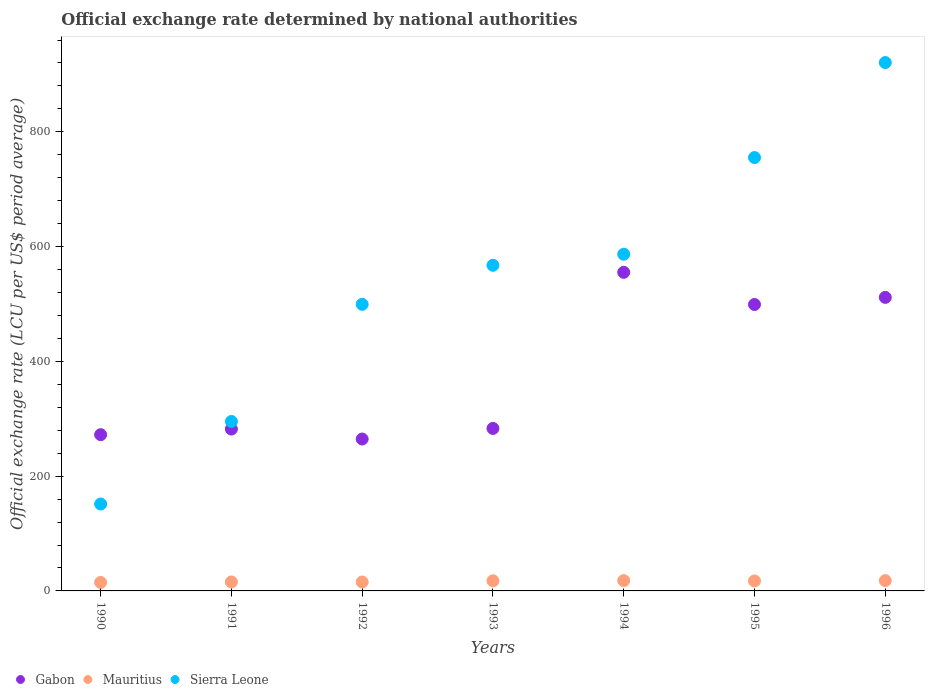Is the number of dotlines equal to the number of legend labels?
Offer a very short reply. Yes. What is the official exchange rate in Sierra Leone in 1996?
Offer a terse response. 920.73. Across all years, what is the maximum official exchange rate in Sierra Leone?
Your answer should be compact. 920.73. Across all years, what is the minimum official exchange rate in Sierra Leone?
Offer a terse response. 151.45. What is the total official exchange rate in Mauritius in the graph?
Provide a succinct answer. 117.02. What is the difference between the official exchange rate in Sierra Leone in 1993 and that in 1996?
Offer a very short reply. -353.27. What is the difference between the official exchange rate in Gabon in 1991 and the official exchange rate in Mauritius in 1996?
Provide a short and direct response. 264.16. What is the average official exchange rate in Mauritius per year?
Ensure brevity in your answer.  16.72. In the year 1990, what is the difference between the official exchange rate in Gabon and official exchange rate in Sierra Leone?
Your answer should be compact. 120.82. In how many years, is the official exchange rate in Mauritius greater than 640 LCU?
Provide a succinct answer. 0. What is the ratio of the official exchange rate in Gabon in 1990 to that in 1992?
Provide a succinct answer. 1.03. Is the difference between the official exchange rate in Gabon in 1994 and 1995 greater than the difference between the official exchange rate in Sierra Leone in 1994 and 1995?
Offer a very short reply. Yes. What is the difference between the highest and the second highest official exchange rate in Mauritius?
Make the answer very short. 0.01. What is the difference between the highest and the lowest official exchange rate in Sierra Leone?
Offer a terse response. 769.29. In how many years, is the official exchange rate in Sierra Leone greater than the average official exchange rate in Sierra Leone taken over all years?
Your answer should be compact. 4. Is the sum of the official exchange rate in Mauritius in 1990 and 1992 greater than the maximum official exchange rate in Gabon across all years?
Offer a very short reply. No. Is it the case that in every year, the sum of the official exchange rate in Mauritius and official exchange rate in Sierra Leone  is greater than the official exchange rate in Gabon?
Offer a very short reply. No. Does the official exchange rate in Sierra Leone monotonically increase over the years?
Your answer should be very brief. Yes. How many years are there in the graph?
Your answer should be very brief. 7. Does the graph contain any zero values?
Your response must be concise. No. Where does the legend appear in the graph?
Make the answer very short. Bottom left. How are the legend labels stacked?
Your answer should be very brief. Horizontal. What is the title of the graph?
Offer a very short reply. Official exchange rate determined by national authorities. Does "Guyana" appear as one of the legend labels in the graph?
Offer a very short reply. No. What is the label or title of the Y-axis?
Ensure brevity in your answer.  Official exchange rate (LCU per US$ period average). What is the Official exchange rate (LCU per US$ period average) of Gabon in 1990?
Make the answer very short. 272.26. What is the Official exchange rate (LCU per US$ period average) of Mauritius in 1990?
Keep it short and to the point. 14.86. What is the Official exchange rate (LCU per US$ period average) of Sierra Leone in 1990?
Give a very brief answer. 151.45. What is the Official exchange rate (LCU per US$ period average) of Gabon in 1991?
Ensure brevity in your answer.  282.11. What is the Official exchange rate (LCU per US$ period average) in Mauritius in 1991?
Provide a short and direct response. 15.65. What is the Official exchange rate (LCU per US$ period average) in Sierra Leone in 1991?
Give a very brief answer. 295.34. What is the Official exchange rate (LCU per US$ period average) of Gabon in 1992?
Provide a short and direct response. 264.69. What is the Official exchange rate (LCU per US$ period average) in Mauritius in 1992?
Offer a very short reply. 15.56. What is the Official exchange rate (LCU per US$ period average) in Sierra Leone in 1992?
Ensure brevity in your answer.  499.44. What is the Official exchange rate (LCU per US$ period average) of Gabon in 1993?
Give a very brief answer. 283.16. What is the Official exchange rate (LCU per US$ period average) of Mauritius in 1993?
Your answer should be compact. 17.65. What is the Official exchange rate (LCU per US$ period average) of Sierra Leone in 1993?
Your answer should be compact. 567.46. What is the Official exchange rate (LCU per US$ period average) in Gabon in 1994?
Keep it short and to the point. 555.2. What is the Official exchange rate (LCU per US$ period average) in Mauritius in 1994?
Offer a very short reply. 17.96. What is the Official exchange rate (LCU per US$ period average) in Sierra Leone in 1994?
Offer a very short reply. 586.74. What is the Official exchange rate (LCU per US$ period average) in Gabon in 1995?
Ensure brevity in your answer.  499.15. What is the Official exchange rate (LCU per US$ period average) in Mauritius in 1995?
Give a very brief answer. 17.39. What is the Official exchange rate (LCU per US$ period average) of Sierra Leone in 1995?
Provide a short and direct response. 755.22. What is the Official exchange rate (LCU per US$ period average) in Gabon in 1996?
Your answer should be compact. 511.55. What is the Official exchange rate (LCU per US$ period average) of Mauritius in 1996?
Make the answer very short. 17.95. What is the Official exchange rate (LCU per US$ period average) of Sierra Leone in 1996?
Provide a short and direct response. 920.73. Across all years, what is the maximum Official exchange rate (LCU per US$ period average) of Gabon?
Ensure brevity in your answer.  555.2. Across all years, what is the maximum Official exchange rate (LCU per US$ period average) in Mauritius?
Provide a short and direct response. 17.96. Across all years, what is the maximum Official exchange rate (LCU per US$ period average) in Sierra Leone?
Your response must be concise. 920.73. Across all years, what is the minimum Official exchange rate (LCU per US$ period average) of Gabon?
Offer a very short reply. 264.69. Across all years, what is the minimum Official exchange rate (LCU per US$ period average) in Mauritius?
Ensure brevity in your answer.  14.86. Across all years, what is the minimum Official exchange rate (LCU per US$ period average) in Sierra Leone?
Your answer should be compact. 151.45. What is the total Official exchange rate (LCU per US$ period average) in Gabon in the graph?
Make the answer very short. 2668.13. What is the total Official exchange rate (LCU per US$ period average) of Mauritius in the graph?
Provide a succinct answer. 117.02. What is the total Official exchange rate (LCU per US$ period average) of Sierra Leone in the graph?
Ensure brevity in your answer.  3776.38. What is the difference between the Official exchange rate (LCU per US$ period average) of Gabon in 1990 and that in 1991?
Give a very brief answer. -9.84. What is the difference between the Official exchange rate (LCU per US$ period average) of Mauritius in 1990 and that in 1991?
Your response must be concise. -0.79. What is the difference between the Official exchange rate (LCU per US$ period average) of Sierra Leone in 1990 and that in 1991?
Give a very brief answer. -143.9. What is the difference between the Official exchange rate (LCU per US$ period average) of Gabon in 1990 and that in 1992?
Give a very brief answer. 7.57. What is the difference between the Official exchange rate (LCU per US$ period average) in Mauritius in 1990 and that in 1992?
Your response must be concise. -0.7. What is the difference between the Official exchange rate (LCU per US$ period average) of Sierra Leone in 1990 and that in 1992?
Provide a short and direct response. -348. What is the difference between the Official exchange rate (LCU per US$ period average) of Gabon in 1990 and that in 1993?
Your answer should be very brief. -10.9. What is the difference between the Official exchange rate (LCU per US$ period average) in Mauritius in 1990 and that in 1993?
Provide a short and direct response. -2.78. What is the difference between the Official exchange rate (LCU per US$ period average) in Sierra Leone in 1990 and that in 1993?
Your answer should be very brief. -416.01. What is the difference between the Official exchange rate (LCU per US$ period average) of Gabon in 1990 and that in 1994?
Provide a short and direct response. -282.94. What is the difference between the Official exchange rate (LCU per US$ period average) in Mauritius in 1990 and that in 1994?
Offer a very short reply. -3.1. What is the difference between the Official exchange rate (LCU per US$ period average) in Sierra Leone in 1990 and that in 1994?
Offer a terse response. -435.29. What is the difference between the Official exchange rate (LCU per US$ period average) of Gabon in 1990 and that in 1995?
Ensure brevity in your answer.  -226.88. What is the difference between the Official exchange rate (LCU per US$ period average) in Mauritius in 1990 and that in 1995?
Provide a succinct answer. -2.52. What is the difference between the Official exchange rate (LCU per US$ period average) in Sierra Leone in 1990 and that in 1995?
Provide a short and direct response. -603.77. What is the difference between the Official exchange rate (LCU per US$ period average) in Gabon in 1990 and that in 1996?
Your response must be concise. -239.29. What is the difference between the Official exchange rate (LCU per US$ period average) of Mauritius in 1990 and that in 1996?
Make the answer very short. -3.08. What is the difference between the Official exchange rate (LCU per US$ period average) in Sierra Leone in 1990 and that in 1996?
Your response must be concise. -769.29. What is the difference between the Official exchange rate (LCU per US$ period average) in Gabon in 1991 and that in 1992?
Provide a short and direct response. 17.42. What is the difference between the Official exchange rate (LCU per US$ period average) in Mauritius in 1991 and that in 1992?
Give a very brief answer. 0.09. What is the difference between the Official exchange rate (LCU per US$ period average) of Sierra Leone in 1991 and that in 1992?
Your response must be concise. -204.1. What is the difference between the Official exchange rate (LCU per US$ period average) of Gabon in 1991 and that in 1993?
Your answer should be very brief. -1.06. What is the difference between the Official exchange rate (LCU per US$ period average) in Mauritius in 1991 and that in 1993?
Make the answer very short. -2. What is the difference between the Official exchange rate (LCU per US$ period average) of Sierra Leone in 1991 and that in 1993?
Provide a succinct answer. -272.11. What is the difference between the Official exchange rate (LCU per US$ period average) in Gabon in 1991 and that in 1994?
Offer a terse response. -273.1. What is the difference between the Official exchange rate (LCU per US$ period average) of Mauritius in 1991 and that in 1994?
Make the answer very short. -2.31. What is the difference between the Official exchange rate (LCU per US$ period average) in Sierra Leone in 1991 and that in 1994?
Provide a succinct answer. -291.4. What is the difference between the Official exchange rate (LCU per US$ period average) of Gabon in 1991 and that in 1995?
Provide a succinct answer. -217.04. What is the difference between the Official exchange rate (LCU per US$ period average) in Mauritius in 1991 and that in 1995?
Your answer should be very brief. -1.73. What is the difference between the Official exchange rate (LCU per US$ period average) of Sierra Leone in 1991 and that in 1995?
Offer a very short reply. -459.87. What is the difference between the Official exchange rate (LCU per US$ period average) of Gabon in 1991 and that in 1996?
Provide a succinct answer. -229.45. What is the difference between the Official exchange rate (LCU per US$ period average) in Mauritius in 1991 and that in 1996?
Your answer should be compact. -2.3. What is the difference between the Official exchange rate (LCU per US$ period average) in Sierra Leone in 1991 and that in 1996?
Provide a succinct answer. -625.39. What is the difference between the Official exchange rate (LCU per US$ period average) of Gabon in 1992 and that in 1993?
Offer a terse response. -18.47. What is the difference between the Official exchange rate (LCU per US$ period average) in Mauritius in 1992 and that in 1993?
Keep it short and to the point. -2.08. What is the difference between the Official exchange rate (LCU per US$ period average) of Sierra Leone in 1992 and that in 1993?
Offer a very short reply. -68.02. What is the difference between the Official exchange rate (LCU per US$ period average) in Gabon in 1992 and that in 1994?
Ensure brevity in your answer.  -290.51. What is the difference between the Official exchange rate (LCU per US$ period average) of Mauritius in 1992 and that in 1994?
Your response must be concise. -2.4. What is the difference between the Official exchange rate (LCU per US$ period average) in Sierra Leone in 1992 and that in 1994?
Offer a very short reply. -87.3. What is the difference between the Official exchange rate (LCU per US$ period average) of Gabon in 1992 and that in 1995?
Make the answer very short. -234.46. What is the difference between the Official exchange rate (LCU per US$ period average) in Mauritius in 1992 and that in 1995?
Ensure brevity in your answer.  -1.82. What is the difference between the Official exchange rate (LCU per US$ period average) in Sierra Leone in 1992 and that in 1995?
Offer a very short reply. -255.77. What is the difference between the Official exchange rate (LCU per US$ period average) in Gabon in 1992 and that in 1996?
Your answer should be very brief. -246.86. What is the difference between the Official exchange rate (LCU per US$ period average) in Mauritius in 1992 and that in 1996?
Give a very brief answer. -2.38. What is the difference between the Official exchange rate (LCU per US$ period average) of Sierra Leone in 1992 and that in 1996?
Offer a very short reply. -421.29. What is the difference between the Official exchange rate (LCU per US$ period average) in Gabon in 1993 and that in 1994?
Offer a very short reply. -272.04. What is the difference between the Official exchange rate (LCU per US$ period average) in Mauritius in 1993 and that in 1994?
Offer a terse response. -0.31. What is the difference between the Official exchange rate (LCU per US$ period average) of Sierra Leone in 1993 and that in 1994?
Provide a short and direct response. -19.28. What is the difference between the Official exchange rate (LCU per US$ period average) in Gabon in 1993 and that in 1995?
Give a very brief answer. -215.99. What is the difference between the Official exchange rate (LCU per US$ period average) in Mauritius in 1993 and that in 1995?
Give a very brief answer. 0.26. What is the difference between the Official exchange rate (LCU per US$ period average) of Sierra Leone in 1993 and that in 1995?
Your response must be concise. -187.76. What is the difference between the Official exchange rate (LCU per US$ period average) in Gabon in 1993 and that in 1996?
Provide a succinct answer. -228.39. What is the difference between the Official exchange rate (LCU per US$ period average) in Sierra Leone in 1993 and that in 1996?
Offer a very short reply. -353.27. What is the difference between the Official exchange rate (LCU per US$ period average) in Gabon in 1994 and that in 1995?
Make the answer very short. 56.06. What is the difference between the Official exchange rate (LCU per US$ period average) in Mauritius in 1994 and that in 1995?
Provide a short and direct response. 0.57. What is the difference between the Official exchange rate (LCU per US$ period average) in Sierra Leone in 1994 and that in 1995?
Provide a short and direct response. -168.48. What is the difference between the Official exchange rate (LCU per US$ period average) in Gabon in 1994 and that in 1996?
Ensure brevity in your answer.  43.65. What is the difference between the Official exchange rate (LCU per US$ period average) of Mauritius in 1994 and that in 1996?
Give a very brief answer. 0.01. What is the difference between the Official exchange rate (LCU per US$ period average) of Sierra Leone in 1994 and that in 1996?
Your answer should be compact. -333.99. What is the difference between the Official exchange rate (LCU per US$ period average) of Gabon in 1995 and that in 1996?
Your response must be concise. -12.4. What is the difference between the Official exchange rate (LCU per US$ period average) in Mauritius in 1995 and that in 1996?
Give a very brief answer. -0.56. What is the difference between the Official exchange rate (LCU per US$ period average) in Sierra Leone in 1995 and that in 1996?
Give a very brief answer. -165.52. What is the difference between the Official exchange rate (LCU per US$ period average) of Gabon in 1990 and the Official exchange rate (LCU per US$ period average) of Mauritius in 1991?
Provide a succinct answer. 256.61. What is the difference between the Official exchange rate (LCU per US$ period average) in Gabon in 1990 and the Official exchange rate (LCU per US$ period average) in Sierra Leone in 1991?
Your answer should be very brief. -23.08. What is the difference between the Official exchange rate (LCU per US$ period average) in Mauritius in 1990 and the Official exchange rate (LCU per US$ period average) in Sierra Leone in 1991?
Your response must be concise. -280.48. What is the difference between the Official exchange rate (LCU per US$ period average) in Gabon in 1990 and the Official exchange rate (LCU per US$ period average) in Mauritius in 1992?
Provide a short and direct response. 256.7. What is the difference between the Official exchange rate (LCU per US$ period average) of Gabon in 1990 and the Official exchange rate (LCU per US$ period average) of Sierra Leone in 1992?
Offer a terse response. -227.18. What is the difference between the Official exchange rate (LCU per US$ period average) of Mauritius in 1990 and the Official exchange rate (LCU per US$ period average) of Sierra Leone in 1992?
Ensure brevity in your answer.  -484.58. What is the difference between the Official exchange rate (LCU per US$ period average) in Gabon in 1990 and the Official exchange rate (LCU per US$ period average) in Mauritius in 1993?
Give a very brief answer. 254.62. What is the difference between the Official exchange rate (LCU per US$ period average) of Gabon in 1990 and the Official exchange rate (LCU per US$ period average) of Sierra Leone in 1993?
Offer a terse response. -295.19. What is the difference between the Official exchange rate (LCU per US$ period average) of Mauritius in 1990 and the Official exchange rate (LCU per US$ period average) of Sierra Leone in 1993?
Your answer should be very brief. -552.6. What is the difference between the Official exchange rate (LCU per US$ period average) in Gabon in 1990 and the Official exchange rate (LCU per US$ period average) in Mauritius in 1994?
Keep it short and to the point. 254.3. What is the difference between the Official exchange rate (LCU per US$ period average) of Gabon in 1990 and the Official exchange rate (LCU per US$ period average) of Sierra Leone in 1994?
Your answer should be compact. -314.47. What is the difference between the Official exchange rate (LCU per US$ period average) of Mauritius in 1990 and the Official exchange rate (LCU per US$ period average) of Sierra Leone in 1994?
Ensure brevity in your answer.  -571.88. What is the difference between the Official exchange rate (LCU per US$ period average) in Gabon in 1990 and the Official exchange rate (LCU per US$ period average) in Mauritius in 1995?
Provide a succinct answer. 254.88. What is the difference between the Official exchange rate (LCU per US$ period average) of Gabon in 1990 and the Official exchange rate (LCU per US$ period average) of Sierra Leone in 1995?
Provide a succinct answer. -482.95. What is the difference between the Official exchange rate (LCU per US$ period average) in Mauritius in 1990 and the Official exchange rate (LCU per US$ period average) in Sierra Leone in 1995?
Your response must be concise. -740.35. What is the difference between the Official exchange rate (LCU per US$ period average) of Gabon in 1990 and the Official exchange rate (LCU per US$ period average) of Mauritius in 1996?
Offer a very short reply. 254.32. What is the difference between the Official exchange rate (LCU per US$ period average) in Gabon in 1990 and the Official exchange rate (LCU per US$ period average) in Sierra Leone in 1996?
Give a very brief answer. -648.47. What is the difference between the Official exchange rate (LCU per US$ period average) in Mauritius in 1990 and the Official exchange rate (LCU per US$ period average) in Sierra Leone in 1996?
Your answer should be very brief. -905.87. What is the difference between the Official exchange rate (LCU per US$ period average) of Gabon in 1991 and the Official exchange rate (LCU per US$ period average) of Mauritius in 1992?
Offer a terse response. 266.54. What is the difference between the Official exchange rate (LCU per US$ period average) of Gabon in 1991 and the Official exchange rate (LCU per US$ period average) of Sierra Leone in 1992?
Offer a terse response. -217.33. What is the difference between the Official exchange rate (LCU per US$ period average) in Mauritius in 1991 and the Official exchange rate (LCU per US$ period average) in Sierra Leone in 1992?
Your response must be concise. -483.79. What is the difference between the Official exchange rate (LCU per US$ period average) of Gabon in 1991 and the Official exchange rate (LCU per US$ period average) of Mauritius in 1993?
Offer a terse response. 264.46. What is the difference between the Official exchange rate (LCU per US$ period average) in Gabon in 1991 and the Official exchange rate (LCU per US$ period average) in Sierra Leone in 1993?
Give a very brief answer. -285.35. What is the difference between the Official exchange rate (LCU per US$ period average) of Mauritius in 1991 and the Official exchange rate (LCU per US$ period average) of Sierra Leone in 1993?
Provide a succinct answer. -551.81. What is the difference between the Official exchange rate (LCU per US$ period average) in Gabon in 1991 and the Official exchange rate (LCU per US$ period average) in Mauritius in 1994?
Offer a very short reply. 264.15. What is the difference between the Official exchange rate (LCU per US$ period average) of Gabon in 1991 and the Official exchange rate (LCU per US$ period average) of Sierra Leone in 1994?
Offer a terse response. -304.63. What is the difference between the Official exchange rate (LCU per US$ period average) in Mauritius in 1991 and the Official exchange rate (LCU per US$ period average) in Sierra Leone in 1994?
Offer a terse response. -571.09. What is the difference between the Official exchange rate (LCU per US$ period average) in Gabon in 1991 and the Official exchange rate (LCU per US$ period average) in Mauritius in 1995?
Provide a succinct answer. 264.72. What is the difference between the Official exchange rate (LCU per US$ period average) of Gabon in 1991 and the Official exchange rate (LCU per US$ period average) of Sierra Leone in 1995?
Make the answer very short. -473.11. What is the difference between the Official exchange rate (LCU per US$ period average) in Mauritius in 1991 and the Official exchange rate (LCU per US$ period average) in Sierra Leone in 1995?
Offer a very short reply. -739.56. What is the difference between the Official exchange rate (LCU per US$ period average) in Gabon in 1991 and the Official exchange rate (LCU per US$ period average) in Mauritius in 1996?
Ensure brevity in your answer.  264.16. What is the difference between the Official exchange rate (LCU per US$ period average) of Gabon in 1991 and the Official exchange rate (LCU per US$ period average) of Sierra Leone in 1996?
Ensure brevity in your answer.  -638.63. What is the difference between the Official exchange rate (LCU per US$ period average) of Mauritius in 1991 and the Official exchange rate (LCU per US$ period average) of Sierra Leone in 1996?
Your response must be concise. -905.08. What is the difference between the Official exchange rate (LCU per US$ period average) in Gabon in 1992 and the Official exchange rate (LCU per US$ period average) in Mauritius in 1993?
Give a very brief answer. 247.04. What is the difference between the Official exchange rate (LCU per US$ period average) in Gabon in 1992 and the Official exchange rate (LCU per US$ period average) in Sierra Leone in 1993?
Your answer should be very brief. -302.77. What is the difference between the Official exchange rate (LCU per US$ period average) of Mauritius in 1992 and the Official exchange rate (LCU per US$ period average) of Sierra Leone in 1993?
Ensure brevity in your answer.  -551.9. What is the difference between the Official exchange rate (LCU per US$ period average) in Gabon in 1992 and the Official exchange rate (LCU per US$ period average) in Mauritius in 1994?
Ensure brevity in your answer.  246.73. What is the difference between the Official exchange rate (LCU per US$ period average) in Gabon in 1992 and the Official exchange rate (LCU per US$ period average) in Sierra Leone in 1994?
Your response must be concise. -322.05. What is the difference between the Official exchange rate (LCU per US$ period average) in Mauritius in 1992 and the Official exchange rate (LCU per US$ period average) in Sierra Leone in 1994?
Offer a terse response. -571.18. What is the difference between the Official exchange rate (LCU per US$ period average) of Gabon in 1992 and the Official exchange rate (LCU per US$ period average) of Mauritius in 1995?
Ensure brevity in your answer.  247.31. What is the difference between the Official exchange rate (LCU per US$ period average) of Gabon in 1992 and the Official exchange rate (LCU per US$ period average) of Sierra Leone in 1995?
Your answer should be compact. -490.52. What is the difference between the Official exchange rate (LCU per US$ period average) of Mauritius in 1992 and the Official exchange rate (LCU per US$ period average) of Sierra Leone in 1995?
Offer a terse response. -739.65. What is the difference between the Official exchange rate (LCU per US$ period average) in Gabon in 1992 and the Official exchange rate (LCU per US$ period average) in Mauritius in 1996?
Make the answer very short. 246.74. What is the difference between the Official exchange rate (LCU per US$ period average) in Gabon in 1992 and the Official exchange rate (LCU per US$ period average) in Sierra Leone in 1996?
Offer a terse response. -656.04. What is the difference between the Official exchange rate (LCU per US$ period average) in Mauritius in 1992 and the Official exchange rate (LCU per US$ period average) in Sierra Leone in 1996?
Provide a succinct answer. -905.17. What is the difference between the Official exchange rate (LCU per US$ period average) of Gabon in 1993 and the Official exchange rate (LCU per US$ period average) of Mauritius in 1994?
Ensure brevity in your answer.  265.2. What is the difference between the Official exchange rate (LCU per US$ period average) in Gabon in 1993 and the Official exchange rate (LCU per US$ period average) in Sierra Leone in 1994?
Make the answer very short. -303.58. What is the difference between the Official exchange rate (LCU per US$ period average) of Mauritius in 1993 and the Official exchange rate (LCU per US$ period average) of Sierra Leone in 1994?
Keep it short and to the point. -569.09. What is the difference between the Official exchange rate (LCU per US$ period average) in Gabon in 1993 and the Official exchange rate (LCU per US$ period average) in Mauritius in 1995?
Provide a succinct answer. 265.78. What is the difference between the Official exchange rate (LCU per US$ period average) of Gabon in 1993 and the Official exchange rate (LCU per US$ period average) of Sierra Leone in 1995?
Provide a short and direct response. -472.05. What is the difference between the Official exchange rate (LCU per US$ period average) in Mauritius in 1993 and the Official exchange rate (LCU per US$ period average) in Sierra Leone in 1995?
Your response must be concise. -737.57. What is the difference between the Official exchange rate (LCU per US$ period average) in Gabon in 1993 and the Official exchange rate (LCU per US$ period average) in Mauritius in 1996?
Ensure brevity in your answer.  265.21. What is the difference between the Official exchange rate (LCU per US$ period average) of Gabon in 1993 and the Official exchange rate (LCU per US$ period average) of Sierra Leone in 1996?
Provide a succinct answer. -637.57. What is the difference between the Official exchange rate (LCU per US$ period average) in Mauritius in 1993 and the Official exchange rate (LCU per US$ period average) in Sierra Leone in 1996?
Give a very brief answer. -903.08. What is the difference between the Official exchange rate (LCU per US$ period average) of Gabon in 1994 and the Official exchange rate (LCU per US$ period average) of Mauritius in 1995?
Offer a very short reply. 537.82. What is the difference between the Official exchange rate (LCU per US$ period average) of Gabon in 1994 and the Official exchange rate (LCU per US$ period average) of Sierra Leone in 1995?
Your response must be concise. -200.01. What is the difference between the Official exchange rate (LCU per US$ period average) of Mauritius in 1994 and the Official exchange rate (LCU per US$ period average) of Sierra Leone in 1995?
Give a very brief answer. -737.26. What is the difference between the Official exchange rate (LCU per US$ period average) of Gabon in 1994 and the Official exchange rate (LCU per US$ period average) of Mauritius in 1996?
Give a very brief answer. 537.26. What is the difference between the Official exchange rate (LCU per US$ period average) of Gabon in 1994 and the Official exchange rate (LCU per US$ period average) of Sierra Leone in 1996?
Keep it short and to the point. -365.53. What is the difference between the Official exchange rate (LCU per US$ period average) in Mauritius in 1994 and the Official exchange rate (LCU per US$ period average) in Sierra Leone in 1996?
Provide a succinct answer. -902.77. What is the difference between the Official exchange rate (LCU per US$ period average) of Gabon in 1995 and the Official exchange rate (LCU per US$ period average) of Mauritius in 1996?
Offer a very short reply. 481.2. What is the difference between the Official exchange rate (LCU per US$ period average) of Gabon in 1995 and the Official exchange rate (LCU per US$ period average) of Sierra Leone in 1996?
Offer a very short reply. -421.58. What is the difference between the Official exchange rate (LCU per US$ period average) in Mauritius in 1995 and the Official exchange rate (LCU per US$ period average) in Sierra Leone in 1996?
Provide a succinct answer. -903.35. What is the average Official exchange rate (LCU per US$ period average) of Gabon per year?
Make the answer very short. 381.16. What is the average Official exchange rate (LCU per US$ period average) in Mauritius per year?
Ensure brevity in your answer.  16.72. What is the average Official exchange rate (LCU per US$ period average) of Sierra Leone per year?
Your answer should be compact. 539.48. In the year 1990, what is the difference between the Official exchange rate (LCU per US$ period average) of Gabon and Official exchange rate (LCU per US$ period average) of Mauritius?
Offer a terse response. 257.4. In the year 1990, what is the difference between the Official exchange rate (LCU per US$ period average) in Gabon and Official exchange rate (LCU per US$ period average) in Sierra Leone?
Give a very brief answer. 120.82. In the year 1990, what is the difference between the Official exchange rate (LCU per US$ period average) in Mauritius and Official exchange rate (LCU per US$ period average) in Sierra Leone?
Give a very brief answer. -136.58. In the year 1991, what is the difference between the Official exchange rate (LCU per US$ period average) of Gabon and Official exchange rate (LCU per US$ period average) of Mauritius?
Ensure brevity in your answer.  266.45. In the year 1991, what is the difference between the Official exchange rate (LCU per US$ period average) of Gabon and Official exchange rate (LCU per US$ period average) of Sierra Leone?
Offer a very short reply. -13.24. In the year 1991, what is the difference between the Official exchange rate (LCU per US$ period average) of Mauritius and Official exchange rate (LCU per US$ period average) of Sierra Leone?
Ensure brevity in your answer.  -279.69. In the year 1992, what is the difference between the Official exchange rate (LCU per US$ period average) in Gabon and Official exchange rate (LCU per US$ period average) in Mauritius?
Ensure brevity in your answer.  249.13. In the year 1992, what is the difference between the Official exchange rate (LCU per US$ period average) in Gabon and Official exchange rate (LCU per US$ period average) in Sierra Leone?
Give a very brief answer. -234.75. In the year 1992, what is the difference between the Official exchange rate (LCU per US$ period average) in Mauritius and Official exchange rate (LCU per US$ period average) in Sierra Leone?
Your answer should be very brief. -483.88. In the year 1993, what is the difference between the Official exchange rate (LCU per US$ period average) in Gabon and Official exchange rate (LCU per US$ period average) in Mauritius?
Your answer should be compact. 265.51. In the year 1993, what is the difference between the Official exchange rate (LCU per US$ period average) of Gabon and Official exchange rate (LCU per US$ period average) of Sierra Leone?
Keep it short and to the point. -284.3. In the year 1993, what is the difference between the Official exchange rate (LCU per US$ period average) of Mauritius and Official exchange rate (LCU per US$ period average) of Sierra Leone?
Keep it short and to the point. -549.81. In the year 1994, what is the difference between the Official exchange rate (LCU per US$ period average) in Gabon and Official exchange rate (LCU per US$ period average) in Mauritius?
Give a very brief answer. 537.24. In the year 1994, what is the difference between the Official exchange rate (LCU per US$ period average) in Gabon and Official exchange rate (LCU per US$ period average) in Sierra Leone?
Your response must be concise. -31.54. In the year 1994, what is the difference between the Official exchange rate (LCU per US$ period average) of Mauritius and Official exchange rate (LCU per US$ period average) of Sierra Leone?
Offer a terse response. -568.78. In the year 1995, what is the difference between the Official exchange rate (LCU per US$ period average) in Gabon and Official exchange rate (LCU per US$ period average) in Mauritius?
Your answer should be compact. 481.76. In the year 1995, what is the difference between the Official exchange rate (LCU per US$ period average) in Gabon and Official exchange rate (LCU per US$ period average) in Sierra Leone?
Keep it short and to the point. -256.07. In the year 1995, what is the difference between the Official exchange rate (LCU per US$ period average) of Mauritius and Official exchange rate (LCU per US$ period average) of Sierra Leone?
Keep it short and to the point. -737.83. In the year 1996, what is the difference between the Official exchange rate (LCU per US$ period average) in Gabon and Official exchange rate (LCU per US$ period average) in Mauritius?
Your response must be concise. 493.6. In the year 1996, what is the difference between the Official exchange rate (LCU per US$ period average) of Gabon and Official exchange rate (LCU per US$ period average) of Sierra Leone?
Provide a succinct answer. -409.18. In the year 1996, what is the difference between the Official exchange rate (LCU per US$ period average) in Mauritius and Official exchange rate (LCU per US$ period average) in Sierra Leone?
Provide a succinct answer. -902.78. What is the ratio of the Official exchange rate (LCU per US$ period average) in Gabon in 1990 to that in 1991?
Give a very brief answer. 0.97. What is the ratio of the Official exchange rate (LCU per US$ period average) in Mauritius in 1990 to that in 1991?
Your answer should be compact. 0.95. What is the ratio of the Official exchange rate (LCU per US$ period average) of Sierra Leone in 1990 to that in 1991?
Keep it short and to the point. 0.51. What is the ratio of the Official exchange rate (LCU per US$ period average) in Gabon in 1990 to that in 1992?
Your answer should be compact. 1.03. What is the ratio of the Official exchange rate (LCU per US$ period average) in Mauritius in 1990 to that in 1992?
Your response must be concise. 0.95. What is the ratio of the Official exchange rate (LCU per US$ period average) in Sierra Leone in 1990 to that in 1992?
Provide a short and direct response. 0.3. What is the ratio of the Official exchange rate (LCU per US$ period average) in Gabon in 1990 to that in 1993?
Give a very brief answer. 0.96. What is the ratio of the Official exchange rate (LCU per US$ period average) of Mauritius in 1990 to that in 1993?
Your answer should be very brief. 0.84. What is the ratio of the Official exchange rate (LCU per US$ period average) in Sierra Leone in 1990 to that in 1993?
Your answer should be compact. 0.27. What is the ratio of the Official exchange rate (LCU per US$ period average) of Gabon in 1990 to that in 1994?
Your answer should be very brief. 0.49. What is the ratio of the Official exchange rate (LCU per US$ period average) in Mauritius in 1990 to that in 1994?
Your answer should be compact. 0.83. What is the ratio of the Official exchange rate (LCU per US$ period average) in Sierra Leone in 1990 to that in 1994?
Make the answer very short. 0.26. What is the ratio of the Official exchange rate (LCU per US$ period average) in Gabon in 1990 to that in 1995?
Your response must be concise. 0.55. What is the ratio of the Official exchange rate (LCU per US$ period average) of Mauritius in 1990 to that in 1995?
Your answer should be compact. 0.85. What is the ratio of the Official exchange rate (LCU per US$ period average) of Sierra Leone in 1990 to that in 1995?
Keep it short and to the point. 0.2. What is the ratio of the Official exchange rate (LCU per US$ period average) in Gabon in 1990 to that in 1996?
Provide a short and direct response. 0.53. What is the ratio of the Official exchange rate (LCU per US$ period average) in Mauritius in 1990 to that in 1996?
Your answer should be compact. 0.83. What is the ratio of the Official exchange rate (LCU per US$ period average) in Sierra Leone in 1990 to that in 1996?
Ensure brevity in your answer.  0.16. What is the ratio of the Official exchange rate (LCU per US$ period average) in Gabon in 1991 to that in 1992?
Your answer should be very brief. 1.07. What is the ratio of the Official exchange rate (LCU per US$ period average) of Sierra Leone in 1991 to that in 1992?
Your answer should be very brief. 0.59. What is the ratio of the Official exchange rate (LCU per US$ period average) of Gabon in 1991 to that in 1993?
Make the answer very short. 1. What is the ratio of the Official exchange rate (LCU per US$ period average) in Mauritius in 1991 to that in 1993?
Your response must be concise. 0.89. What is the ratio of the Official exchange rate (LCU per US$ period average) of Sierra Leone in 1991 to that in 1993?
Keep it short and to the point. 0.52. What is the ratio of the Official exchange rate (LCU per US$ period average) of Gabon in 1991 to that in 1994?
Offer a very short reply. 0.51. What is the ratio of the Official exchange rate (LCU per US$ period average) of Mauritius in 1991 to that in 1994?
Your answer should be compact. 0.87. What is the ratio of the Official exchange rate (LCU per US$ period average) of Sierra Leone in 1991 to that in 1994?
Your answer should be compact. 0.5. What is the ratio of the Official exchange rate (LCU per US$ period average) in Gabon in 1991 to that in 1995?
Your response must be concise. 0.57. What is the ratio of the Official exchange rate (LCU per US$ period average) in Mauritius in 1991 to that in 1995?
Ensure brevity in your answer.  0.9. What is the ratio of the Official exchange rate (LCU per US$ period average) in Sierra Leone in 1991 to that in 1995?
Offer a terse response. 0.39. What is the ratio of the Official exchange rate (LCU per US$ period average) of Gabon in 1991 to that in 1996?
Provide a succinct answer. 0.55. What is the ratio of the Official exchange rate (LCU per US$ period average) of Mauritius in 1991 to that in 1996?
Make the answer very short. 0.87. What is the ratio of the Official exchange rate (LCU per US$ period average) in Sierra Leone in 1991 to that in 1996?
Ensure brevity in your answer.  0.32. What is the ratio of the Official exchange rate (LCU per US$ period average) of Gabon in 1992 to that in 1993?
Ensure brevity in your answer.  0.93. What is the ratio of the Official exchange rate (LCU per US$ period average) in Mauritius in 1992 to that in 1993?
Your answer should be very brief. 0.88. What is the ratio of the Official exchange rate (LCU per US$ period average) in Sierra Leone in 1992 to that in 1993?
Keep it short and to the point. 0.88. What is the ratio of the Official exchange rate (LCU per US$ period average) of Gabon in 1992 to that in 1994?
Provide a short and direct response. 0.48. What is the ratio of the Official exchange rate (LCU per US$ period average) in Mauritius in 1992 to that in 1994?
Provide a succinct answer. 0.87. What is the ratio of the Official exchange rate (LCU per US$ period average) in Sierra Leone in 1992 to that in 1994?
Provide a short and direct response. 0.85. What is the ratio of the Official exchange rate (LCU per US$ period average) of Gabon in 1992 to that in 1995?
Offer a very short reply. 0.53. What is the ratio of the Official exchange rate (LCU per US$ period average) in Mauritius in 1992 to that in 1995?
Offer a very short reply. 0.9. What is the ratio of the Official exchange rate (LCU per US$ period average) of Sierra Leone in 1992 to that in 1995?
Provide a succinct answer. 0.66. What is the ratio of the Official exchange rate (LCU per US$ period average) in Gabon in 1992 to that in 1996?
Give a very brief answer. 0.52. What is the ratio of the Official exchange rate (LCU per US$ period average) of Mauritius in 1992 to that in 1996?
Offer a very short reply. 0.87. What is the ratio of the Official exchange rate (LCU per US$ period average) in Sierra Leone in 1992 to that in 1996?
Your answer should be very brief. 0.54. What is the ratio of the Official exchange rate (LCU per US$ period average) of Gabon in 1993 to that in 1994?
Offer a very short reply. 0.51. What is the ratio of the Official exchange rate (LCU per US$ period average) in Mauritius in 1993 to that in 1994?
Ensure brevity in your answer.  0.98. What is the ratio of the Official exchange rate (LCU per US$ period average) in Sierra Leone in 1993 to that in 1994?
Ensure brevity in your answer.  0.97. What is the ratio of the Official exchange rate (LCU per US$ period average) in Gabon in 1993 to that in 1995?
Keep it short and to the point. 0.57. What is the ratio of the Official exchange rate (LCU per US$ period average) of Mauritius in 1993 to that in 1995?
Ensure brevity in your answer.  1.02. What is the ratio of the Official exchange rate (LCU per US$ period average) of Sierra Leone in 1993 to that in 1995?
Keep it short and to the point. 0.75. What is the ratio of the Official exchange rate (LCU per US$ period average) in Gabon in 1993 to that in 1996?
Your response must be concise. 0.55. What is the ratio of the Official exchange rate (LCU per US$ period average) of Mauritius in 1993 to that in 1996?
Offer a very short reply. 0.98. What is the ratio of the Official exchange rate (LCU per US$ period average) in Sierra Leone in 1993 to that in 1996?
Ensure brevity in your answer.  0.62. What is the ratio of the Official exchange rate (LCU per US$ period average) of Gabon in 1994 to that in 1995?
Your answer should be compact. 1.11. What is the ratio of the Official exchange rate (LCU per US$ period average) in Mauritius in 1994 to that in 1995?
Give a very brief answer. 1.03. What is the ratio of the Official exchange rate (LCU per US$ period average) of Sierra Leone in 1994 to that in 1995?
Your answer should be very brief. 0.78. What is the ratio of the Official exchange rate (LCU per US$ period average) in Gabon in 1994 to that in 1996?
Give a very brief answer. 1.09. What is the ratio of the Official exchange rate (LCU per US$ period average) in Sierra Leone in 1994 to that in 1996?
Make the answer very short. 0.64. What is the ratio of the Official exchange rate (LCU per US$ period average) in Gabon in 1995 to that in 1996?
Your response must be concise. 0.98. What is the ratio of the Official exchange rate (LCU per US$ period average) in Mauritius in 1995 to that in 1996?
Make the answer very short. 0.97. What is the ratio of the Official exchange rate (LCU per US$ period average) in Sierra Leone in 1995 to that in 1996?
Provide a succinct answer. 0.82. What is the difference between the highest and the second highest Official exchange rate (LCU per US$ period average) in Gabon?
Provide a succinct answer. 43.65. What is the difference between the highest and the second highest Official exchange rate (LCU per US$ period average) of Mauritius?
Make the answer very short. 0.01. What is the difference between the highest and the second highest Official exchange rate (LCU per US$ period average) of Sierra Leone?
Your response must be concise. 165.52. What is the difference between the highest and the lowest Official exchange rate (LCU per US$ period average) in Gabon?
Your answer should be compact. 290.51. What is the difference between the highest and the lowest Official exchange rate (LCU per US$ period average) of Mauritius?
Offer a very short reply. 3.1. What is the difference between the highest and the lowest Official exchange rate (LCU per US$ period average) of Sierra Leone?
Your answer should be very brief. 769.29. 